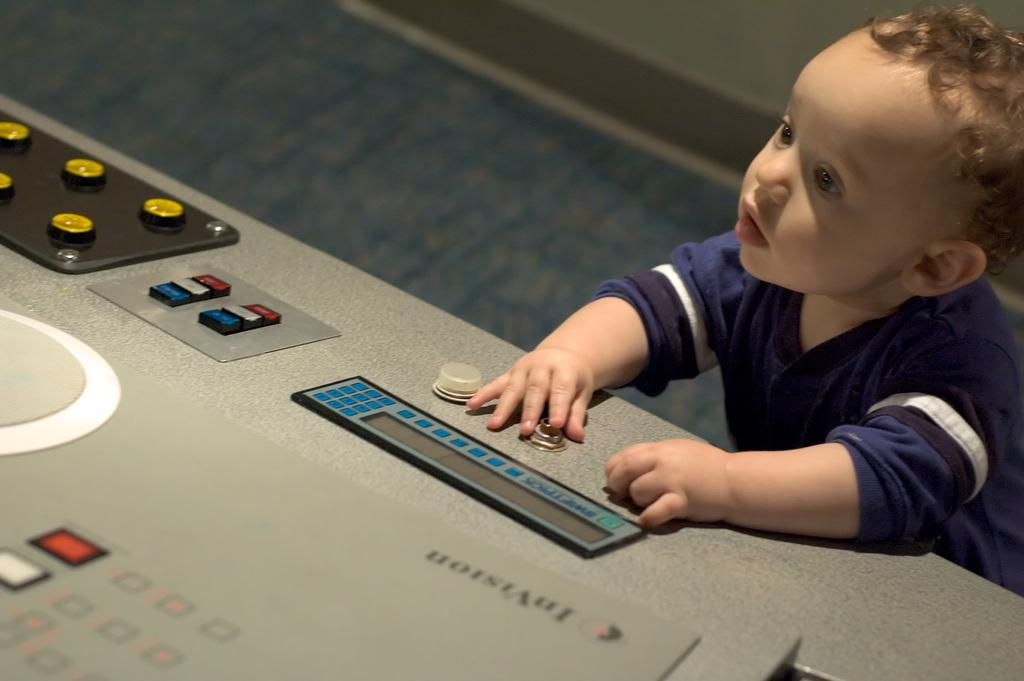What is the main subject of the image? There is a boy standing in the image. What is the boy holding in the image? The boy is holding a nob. What other objects can be seen in the image besides the boy? There are knobs and buttons in the image. What is the surface that the boy is standing on in the image? There is a floor at the bottom of the image. Can you describe the woman holding a goat in the image? There is no woman or goat present in the image; it features a boy holding a nob. What type of ray is visible in the image? There is no ray present in the image. 